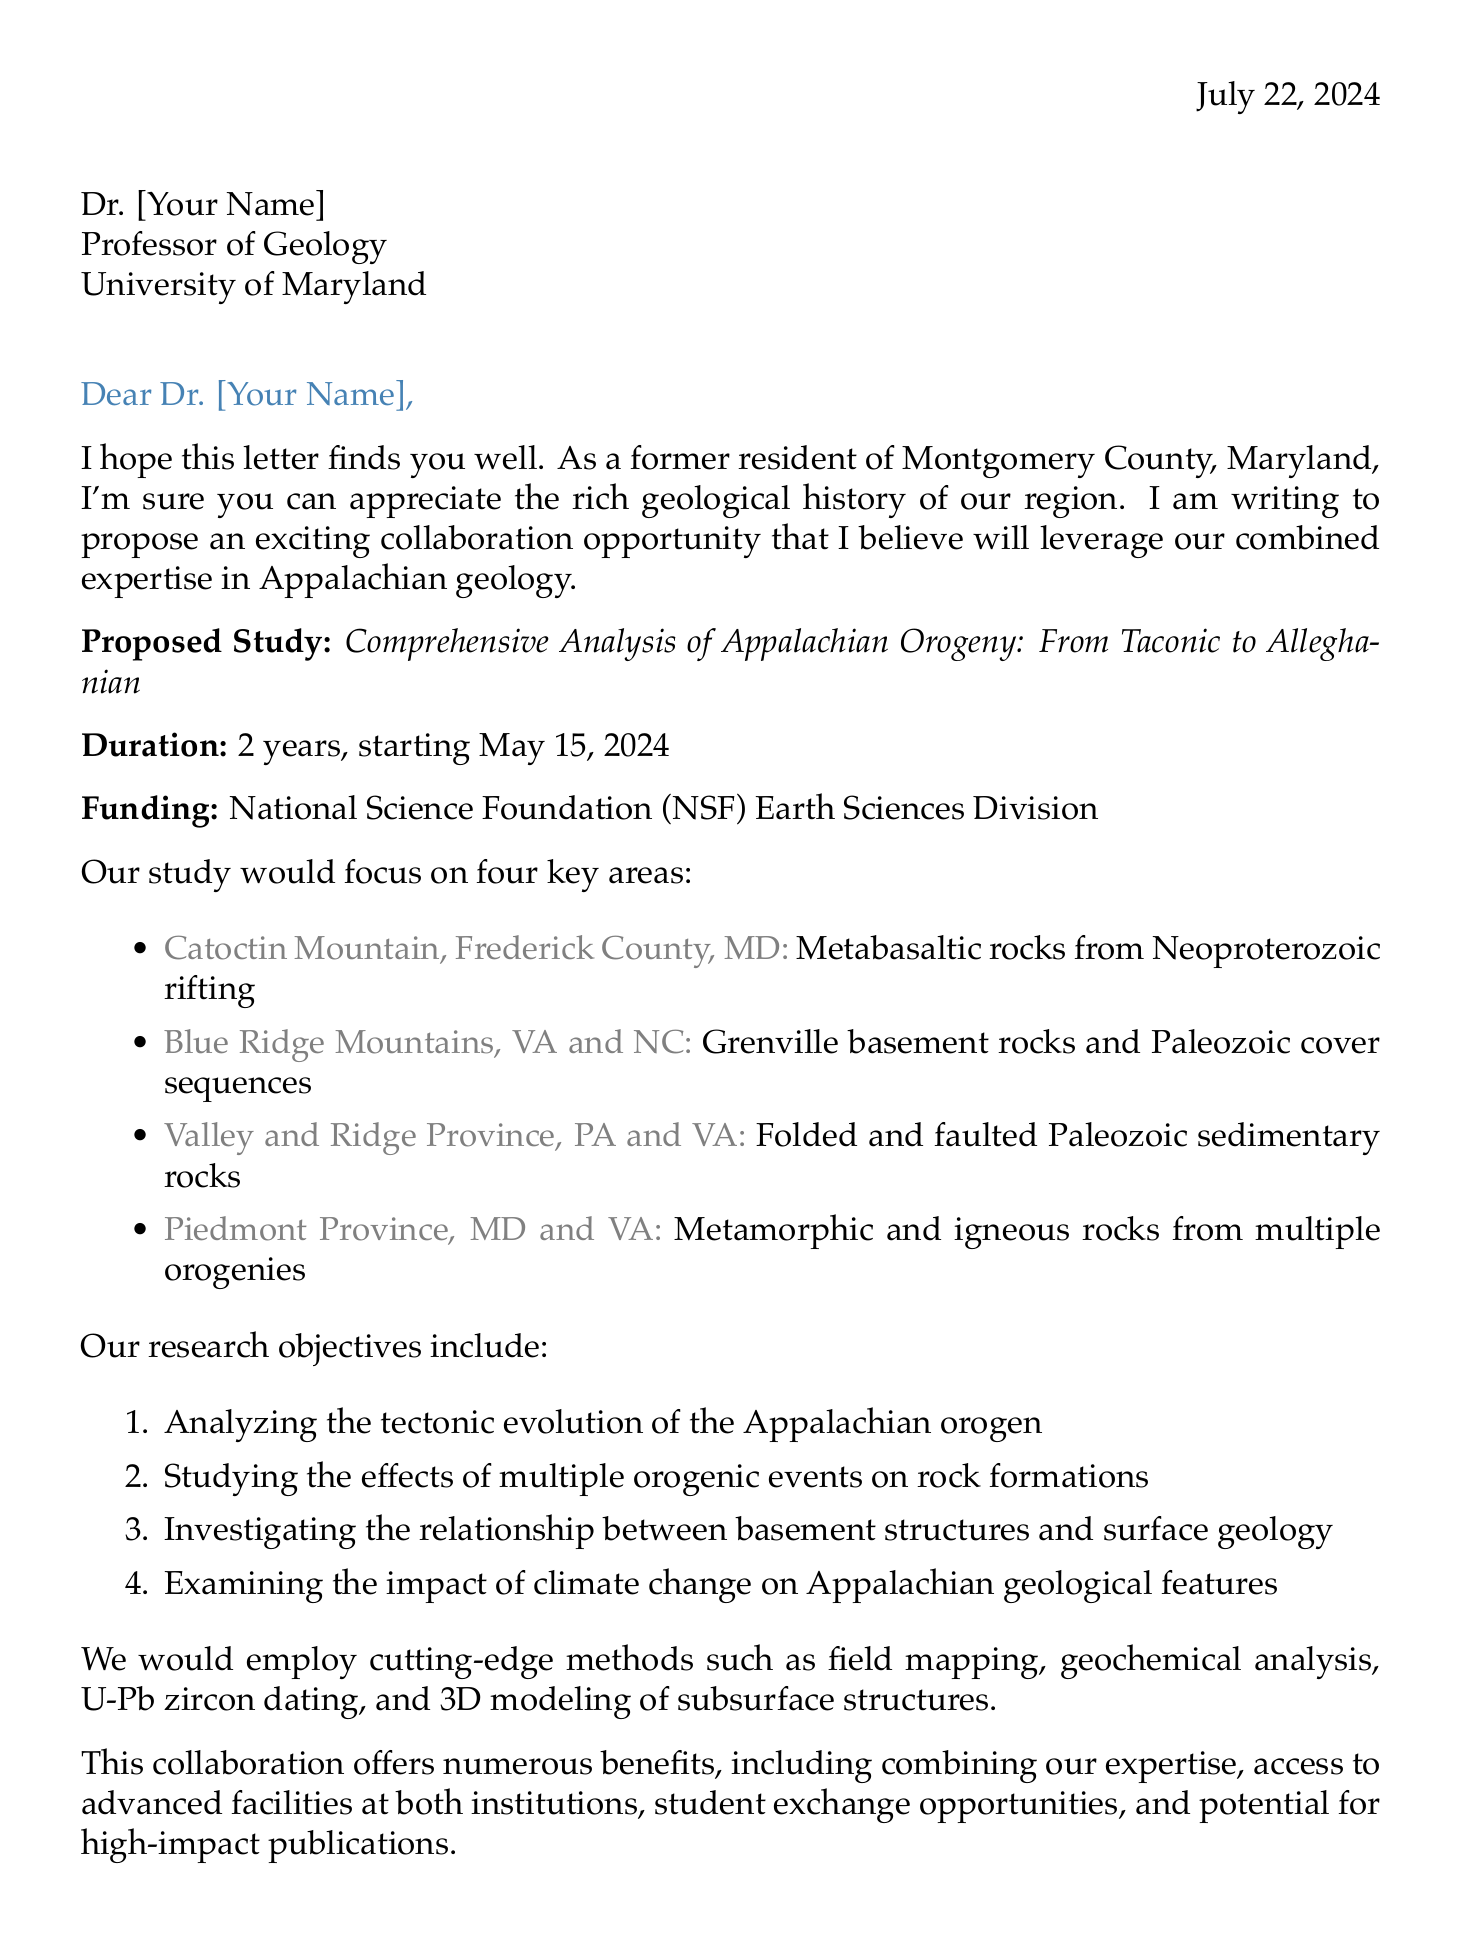What is the title of the proposed study? The title of the proposed study is mentioned in the introduction of the letter.
Answer: Comprehensive Analysis of Appalachian Orogeny: From Taconic to Alleghanian Who is the sender of the letter? The sender's details are provided at the beginning of the letter.
Answer: Dr. Emily Rothschild What is the start date of the proposed study? The start date is explicitly stated in the proposed study section.
Answer: May 15, 2024 What research method involves geochronology? This method is mentioned in the proposed methods section of the letter.
Answer: U-Pb zircon dating Which funding source is mentioned for the study? The funding source is noted in the proposed study overview.
Answer: National Science Foundation (NSF) Earth Sciences Division What geographic area is associated with folded and faulted Paleozoic sedimentary rocks? This information is included in the key study areas listed.
Answer: Valley and Ridge Province What are the logistics benefits mentioned for the collaboration? The letter outlines advantages related to local knowledge and proximity to field sites.
Answer: Proximity to field sites and familiarity with local geology Who is a mutual colleague mentioned in the letter? The letter refers to a colleague to establish personal connections.
Answer: Dr. Robert Johnson What is one of the research objectives? The document outlines specific objectives to clarify the study's goals.
Answer: Analyze the tectonic evolution of the Appalachian orogen 